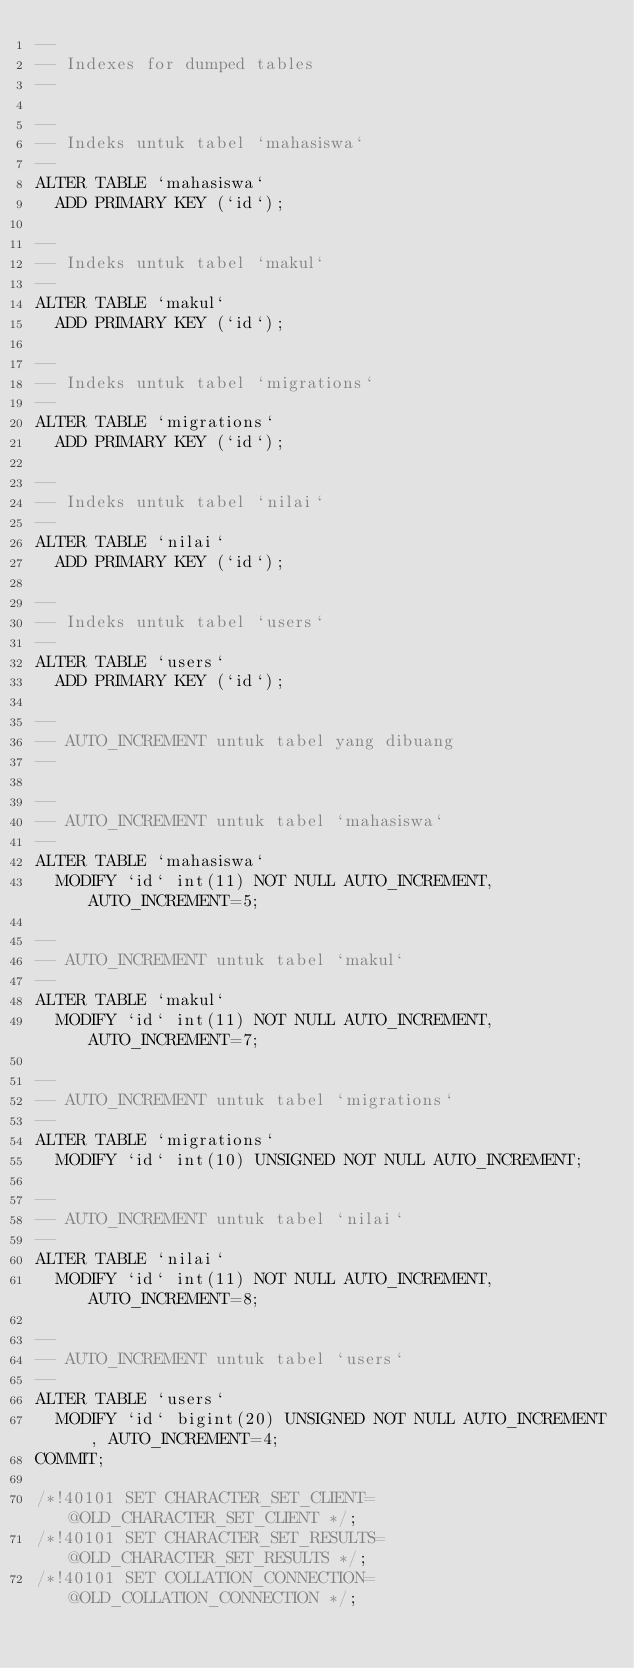<code> <loc_0><loc_0><loc_500><loc_500><_SQL_>--
-- Indexes for dumped tables
--

--
-- Indeks untuk tabel `mahasiswa`
--
ALTER TABLE `mahasiswa`
  ADD PRIMARY KEY (`id`);

--
-- Indeks untuk tabel `makul`
--
ALTER TABLE `makul`
  ADD PRIMARY KEY (`id`);

--
-- Indeks untuk tabel `migrations`
--
ALTER TABLE `migrations`
  ADD PRIMARY KEY (`id`);

--
-- Indeks untuk tabel `nilai`
--
ALTER TABLE `nilai`
  ADD PRIMARY KEY (`id`);

--
-- Indeks untuk tabel `users`
--
ALTER TABLE `users`
  ADD PRIMARY KEY (`id`);

--
-- AUTO_INCREMENT untuk tabel yang dibuang
--

--
-- AUTO_INCREMENT untuk tabel `mahasiswa`
--
ALTER TABLE `mahasiswa`
  MODIFY `id` int(11) NOT NULL AUTO_INCREMENT, AUTO_INCREMENT=5;

--
-- AUTO_INCREMENT untuk tabel `makul`
--
ALTER TABLE `makul`
  MODIFY `id` int(11) NOT NULL AUTO_INCREMENT, AUTO_INCREMENT=7;

--
-- AUTO_INCREMENT untuk tabel `migrations`
--
ALTER TABLE `migrations`
  MODIFY `id` int(10) UNSIGNED NOT NULL AUTO_INCREMENT;

--
-- AUTO_INCREMENT untuk tabel `nilai`
--
ALTER TABLE `nilai`
  MODIFY `id` int(11) NOT NULL AUTO_INCREMENT, AUTO_INCREMENT=8;

--
-- AUTO_INCREMENT untuk tabel `users`
--
ALTER TABLE `users`
  MODIFY `id` bigint(20) UNSIGNED NOT NULL AUTO_INCREMENT, AUTO_INCREMENT=4;
COMMIT;

/*!40101 SET CHARACTER_SET_CLIENT=@OLD_CHARACTER_SET_CLIENT */;
/*!40101 SET CHARACTER_SET_RESULTS=@OLD_CHARACTER_SET_RESULTS */;
/*!40101 SET COLLATION_CONNECTION=@OLD_COLLATION_CONNECTION */;
</code> 